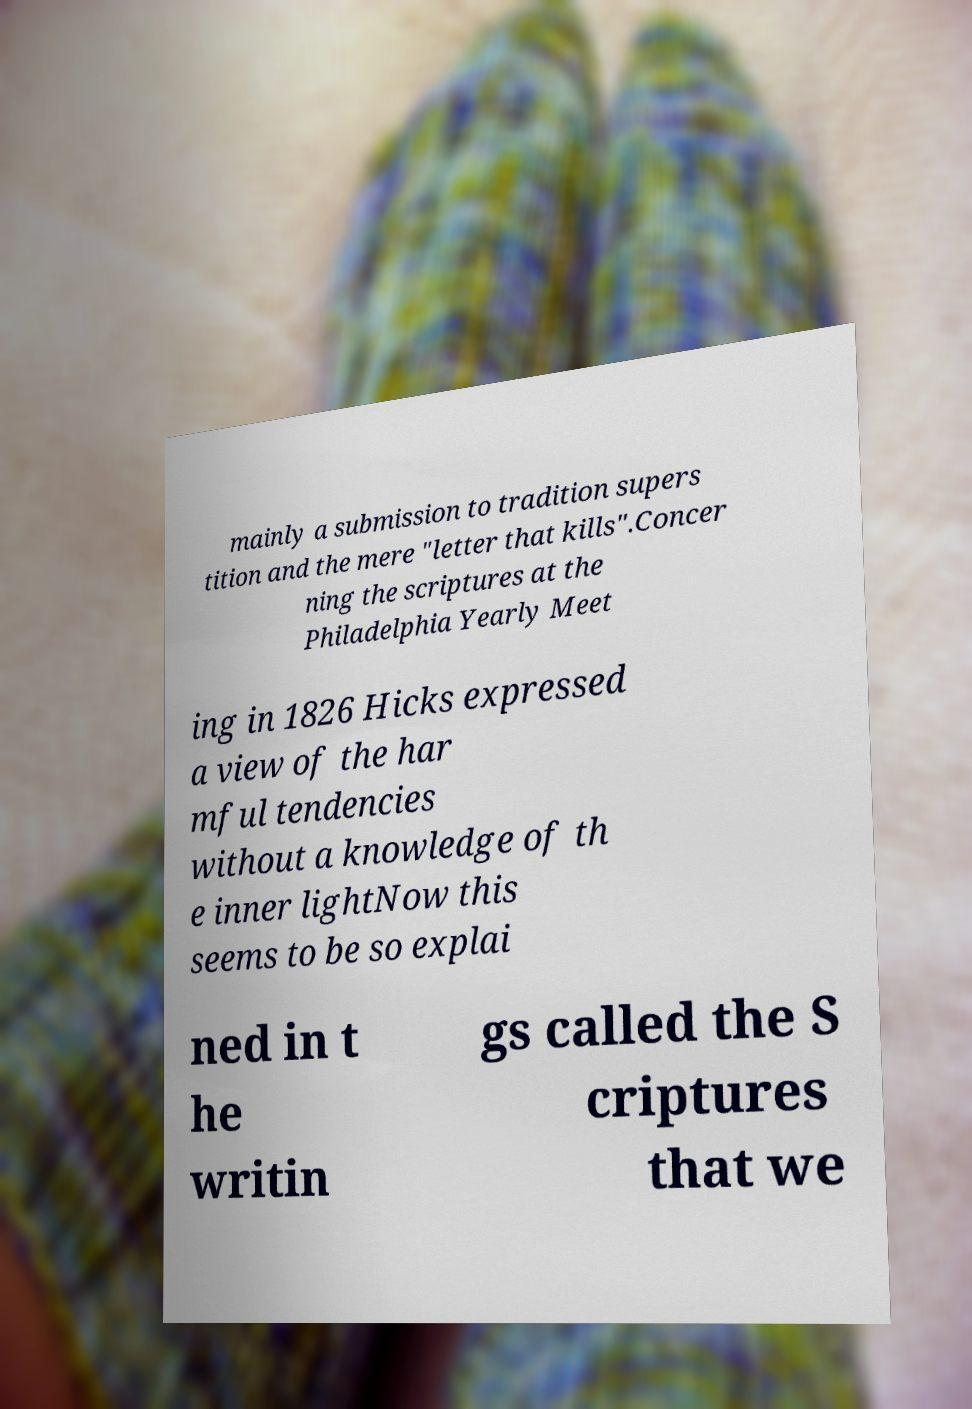Could you extract and type out the text from this image? mainly a submission to tradition supers tition and the mere "letter that kills".Concer ning the scriptures at the Philadelphia Yearly Meet ing in 1826 Hicks expressed a view of the har mful tendencies without a knowledge of th e inner lightNow this seems to be so explai ned in t he writin gs called the S criptures that we 